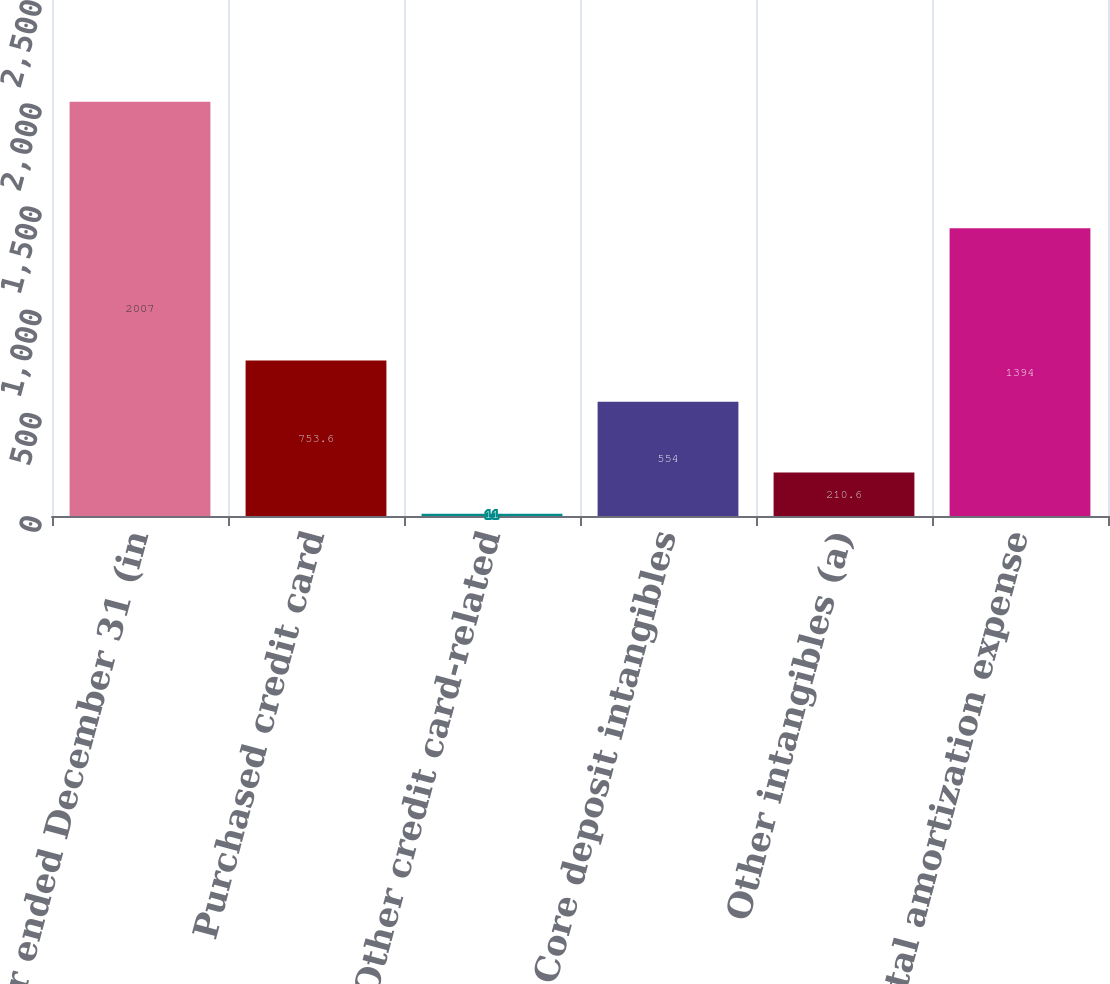Convert chart. <chart><loc_0><loc_0><loc_500><loc_500><bar_chart><fcel>Year ended December 31 (in<fcel>Purchased credit card<fcel>Other credit card-related<fcel>Core deposit intangibles<fcel>Other intangibles (a)<fcel>Total amortization expense<nl><fcel>2007<fcel>753.6<fcel>11<fcel>554<fcel>210.6<fcel>1394<nl></chart> 